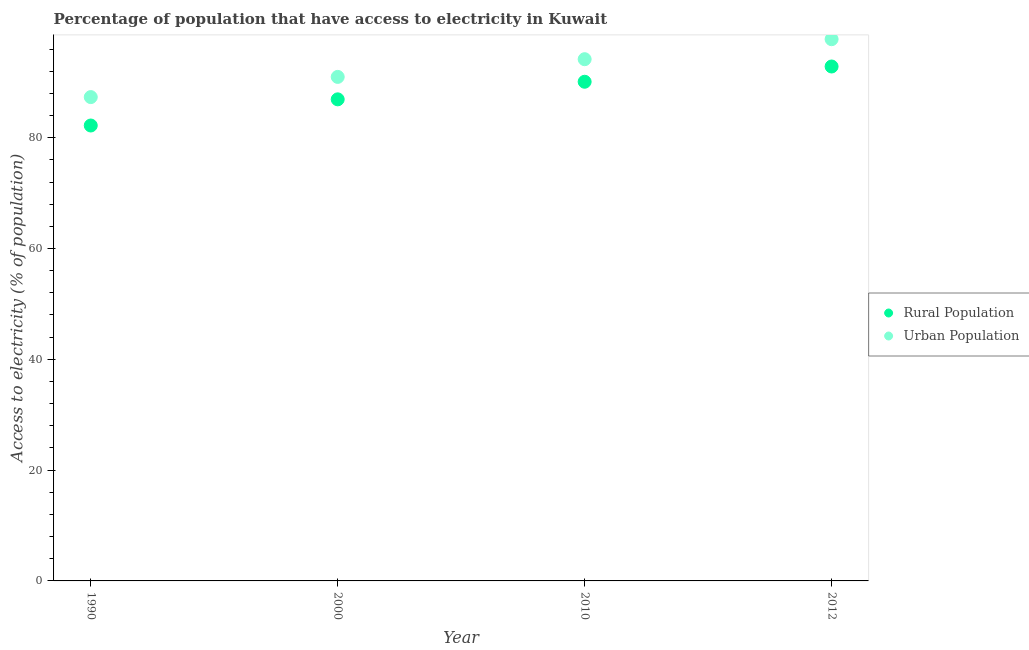Is the number of dotlines equal to the number of legend labels?
Your answer should be very brief. Yes. What is the percentage of rural population having access to electricity in 2000?
Offer a terse response. 86.93. Across all years, what is the maximum percentage of urban population having access to electricity?
Your answer should be compact. 97.78. Across all years, what is the minimum percentage of rural population having access to electricity?
Your answer should be compact. 82.2. In which year was the percentage of urban population having access to electricity minimum?
Provide a succinct answer. 1990. What is the total percentage of urban population having access to electricity in the graph?
Provide a short and direct response. 370.26. What is the difference between the percentage of rural population having access to electricity in 1990 and that in 2000?
Your response must be concise. -4.72. What is the difference between the percentage of urban population having access to electricity in 1990 and the percentage of rural population having access to electricity in 2000?
Provide a short and direct response. 0.41. What is the average percentage of urban population having access to electricity per year?
Your answer should be very brief. 92.57. In the year 2012, what is the difference between the percentage of urban population having access to electricity and percentage of rural population having access to electricity?
Your response must be concise. 4.93. In how many years, is the percentage of rural population having access to electricity greater than 24 %?
Provide a succinct answer. 4. What is the ratio of the percentage of urban population having access to electricity in 2010 to that in 2012?
Provide a succinct answer. 0.96. What is the difference between the highest and the second highest percentage of urban population having access to electricity?
Your answer should be very brief. 3.61. What is the difference between the highest and the lowest percentage of rural population having access to electricity?
Provide a short and direct response. 10.65. In how many years, is the percentage of rural population having access to electricity greater than the average percentage of rural population having access to electricity taken over all years?
Provide a short and direct response. 2. Is the percentage of rural population having access to electricity strictly greater than the percentage of urban population having access to electricity over the years?
Your response must be concise. No. How many years are there in the graph?
Make the answer very short. 4. What is the difference between two consecutive major ticks on the Y-axis?
Your response must be concise. 20. Are the values on the major ticks of Y-axis written in scientific E-notation?
Your answer should be very brief. No. Does the graph contain grids?
Your answer should be compact. No. Where does the legend appear in the graph?
Offer a very short reply. Center right. How many legend labels are there?
Offer a very short reply. 2. How are the legend labels stacked?
Make the answer very short. Vertical. What is the title of the graph?
Make the answer very short. Percentage of population that have access to electricity in Kuwait. Does "% of gross capital formation" appear as one of the legend labels in the graph?
Your answer should be compact. No. What is the label or title of the X-axis?
Offer a very short reply. Year. What is the label or title of the Y-axis?
Provide a succinct answer. Access to electricity (% of population). What is the Access to electricity (% of population) of Rural Population in 1990?
Make the answer very short. 82.2. What is the Access to electricity (% of population) in Urban Population in 1990?
Give a very brief answer. 87.33. What is the Access to electricity (% of population) in Rural Population in 2000?
Ensure brevity in your answer.  86.93. What is the Access to electricity (% of population) of Urban Population in 2000?
Keep it short and to the point. 90.98. What is the Access to electricity (% of population) in Rural Population in 2010?
Your answer should be compact. 90.1. What is the Access to electricity (% of population) of Urban Population in 2010?
Keep it short and to the point. 94.17. What is the Access to electricity (% of population) of Rural Population in 2012?
Your answer should be very brief. 92.85. What is the Access to electricity (% of population) in Urban Population in 2012?
Keep it short and to the point. 97.78. Across all years, what is the maximum Access to electricity (% of population) of Rural Population?
Keep it short and to the point. 92.85. Across all years, what is the maximum Access to electricity (% of population) in Urban Population?
Provide a short and direct response. 97.78. Across all years, what is the minimum Access to electricity (% of population) in Rural Population?
Ensure brevity in your answer.  82.2. Across all years, what is the minimum Access to electricity (% of population) in Urban Population?
Keep it short and to the point. 87.33. What is the total Access to electricity (% of population) of Rural Population in the graph?
Your answer should be very brief. 352.08. What is the total Access to electricity (% of population) in Urban Population in the graph?
Provide a short and direct response. 370.26. What is the difference between the Access to electricity (% of population) of Rural Population in 1990 and that in 2000?
Keep it short and to the point. -4.72. What is the difference between the Access to electricity (% of population) of Urban Population in 1990 and that in 2000?
Your answer should be very brief. -3.64. What is the difference between the Access to electricity (% of population) in Rural Population in 1990 and that in 2010?
Provide a short and direct response. -7.9. What is the difference between the Access to electricity (% of population) of Urban Population in 1990 and that in 2010?
Offer a terse response. -6.84. What is the difference between the Access to electricity (% of population) of Rural Population in 1990 and that in 2012?
Offer a terse response. -10.65. What is the difference between the Access to electricity (% of population) of Urban Population in 1990 and that in 2012?
Offer a terse response. -10.45. What is the difference between the Access to electricity (% of population) in Rural Population in 2000 and that in 2010?
Your answer should be very brief. -3.17. What is the difference between the Access to electricity (% of population) in Urban Population in 2000 and that in 2010?
Offer a very short reply. -3.2. What is the difference between the Access to electricity (% of population) in Rural Population in 2000 and that in 2012?
Your answer should be very brief. -5.93. What is the difference between the Access to electricity (% of population) of Urban Population in 2000 and that in 2012?
Make the answer very short. -6.81. What is the difference between the Access to electricity (% of population) of Rural Population in 2010 and that in 2012?
Give a very brief answer. -2.75. What is the difference between the Access to electricity (% of population) in Urban Population in 2010 and that in 2012?
Your answer should be compact. -3.61. What is the difference between the Access to electricity (% of population) of Rural Population in 1990 and the Access to electricity (% of population) of Urban Population in 2000?
Your response must be concise. -8.77. What is the difference between the Access to electricity (% of population) of Rural Population in 1990 and the Access to electricity (% of population) of Urban Population in 2010?
Offer a very short reply. -11.97. What is the difference between the Access to electricity (% of population) of Rural Population in 1990 and the Access to electricity (% of population) of Urban Population in 2012?
Offer a terse response. -15.58. What is the difference between the Access to electricity (% of population) in Rural Population in 2000 and the Access to electricity (% of population) in Urban Population in 2010?
Provide a short and direct response. -7.25. What is the difference between the Access to electricity (% of population) in Rural Population in 2000 and the Access to electricity (% of population) in Urban Population in 2012?
Ensure brevity in your answer.  -10.86. What is the difference between the Access to electricity (% of population) of Rural Population in 2010 and the Access to electricity (% of population) of Urban Population in 2012?
Offer a very short reply. -7.68. What is the average Access to electricity (% of population) of Rural Population per year?
Your answer should be very brief. 88.02. What is the average Access to electricity (% of population) of Urban Population per year?
Give a very brief answer. 92.57. In the year 1990, what is the difference between the Access to electricity (% of population) of Rural Population and Access to electricity (% of population) of Urban Population?
Give a very brief answer. -5.13. In the year 2000, what is the difference between the Access to electricity (% of population) of Rural Population and Access to electricity (% of population) of Urban Population?
Offer a very short reply. -4.05. In the year 2010, what is the difference between the Access to electricity (% of population) in Rural Population and Access to electricity (% of population) in Urban Population?
Provide a short and direct response. -4.07. In the year 2012, what is the difference between the Access to electricity (% of population) of Rural Population and Access to electricity (% of population) of Urban Population?
Keep it short and to the point. -4.93. What is the ratio of the Access to electricity (% of population) of Rural Population in 1990 to that in 2000?
Your answer should be compact. 0.95. What is the ratio of the Access to electricity (% of population) in Urban Population in 1990 to that in 2000?
Make the answer very short. 0.96. What is the ratio of the Access to electricity (% of population) of Rural Population in 1990 to that in 2010?
Your response must be concise. 0.91. What is the ratio of the Access to electricity (% of population) of Urban Population in 1990 to that in 2010?
Your answer should be compact. 0.93. What is the ratio of the Access to electricity (% of population) in Rural Population in 1990 to that in 2012?
Ensure brevity in your answer.  0.89. What is the ratio of the Access to electricity (% of population) of Urban Population in 1990 to that in 2012?
Keep it short and to the point. 0.89. What is the ratio of the Access to electricity (% of population) in Rural Population in 2000 to that in 2010?
Give a very brief answer. 0.96. What is the ratio of the Access to electricity (% of population) of Urban Population in 2000 to that in 2010?
Give a very brief answer. 0.97. What is the ratio of the Access to electricity (% of population) in Rural Population in 2000 to that in 2012?
Provide a short and direct response. 0.94. What is the ratio of the Access to electricity (% of population) in Urban Population in 2000 to that in 2012?
Provide a short and direct response. 0.93. What is the ratio of the Access to electricity (% of population) in Rural Population in 2010 to that in 2012?
Provide a succinct answer. 0.97. What is the ratio of the Access to electricity (% of population) in Urban Population in 2010 to that in 2012?
Ensure brevity in your answer.  0.96. What is the difference between the highest and the second highest Access to electricity (% of population) in Rural Population?
Offer a very short reply. 2.75. What is the difference between the highest and the second highest Access to electricity (% of population) of Urban Population?
Your response must be concise. 3.61. What is the difference between the highest and the lowest Access to electricity (% of population) in Rural Population?
Ensure brevity in your answer.  10.65. What is the difference between the highest and the lowest Access to electricity (% of population) in Urban Population?
Keep it short and to the point. 10.45. 